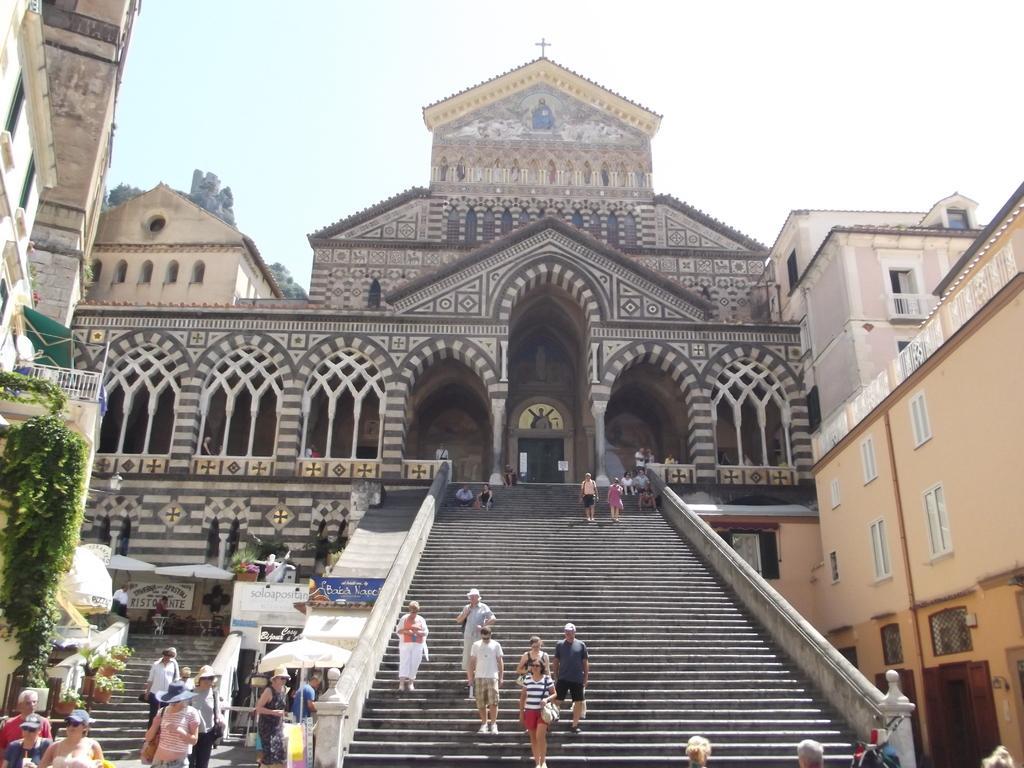Could you give a brief overview of what you see in this image? In this image there are people walking on the stairs. There are tents. On the left side of the image there are flower pots, plants. In the background of the image there are buildings and sky. 